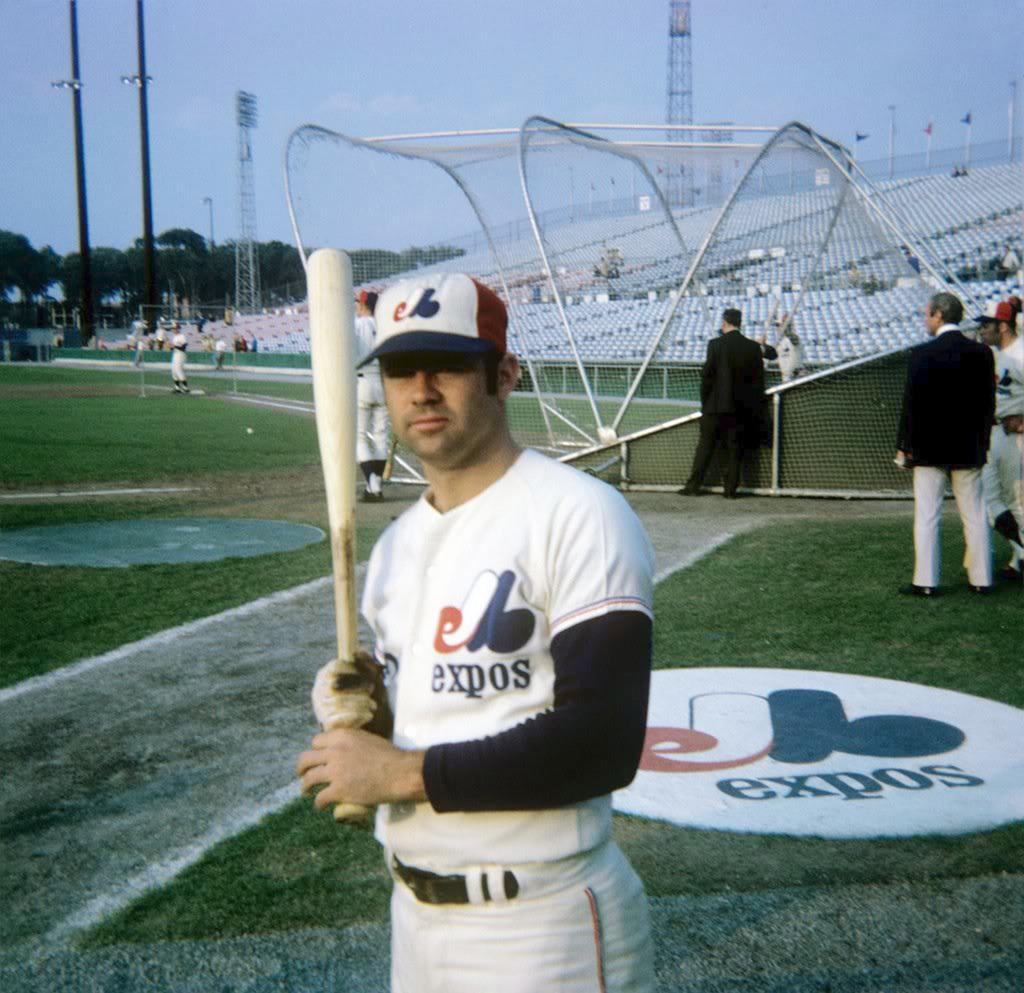<image>
Provide a brief description of the given image. A baseball player poses in front of the JB Expos logo that is painted on the field. 